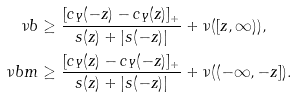<formula> <loc_0><loc_0><loc_500><loc_500>\nu b & \geq \frac { [ c _ { Y } ( - z ) - c _ { Y } ( z ) ] _ { + } } { s ( z ) + | s ( - z ) | } + \nu ( [ z , \infty ) ) , \\ \nu b m & \geq \frac { [ c _ { Y } ( z ) - c _ { Y } ( - z ) ] _ { + } } { s ( z ) + | s ( - z ) | } + \nu ( ( - \infty , - z ] ) .</formula> 